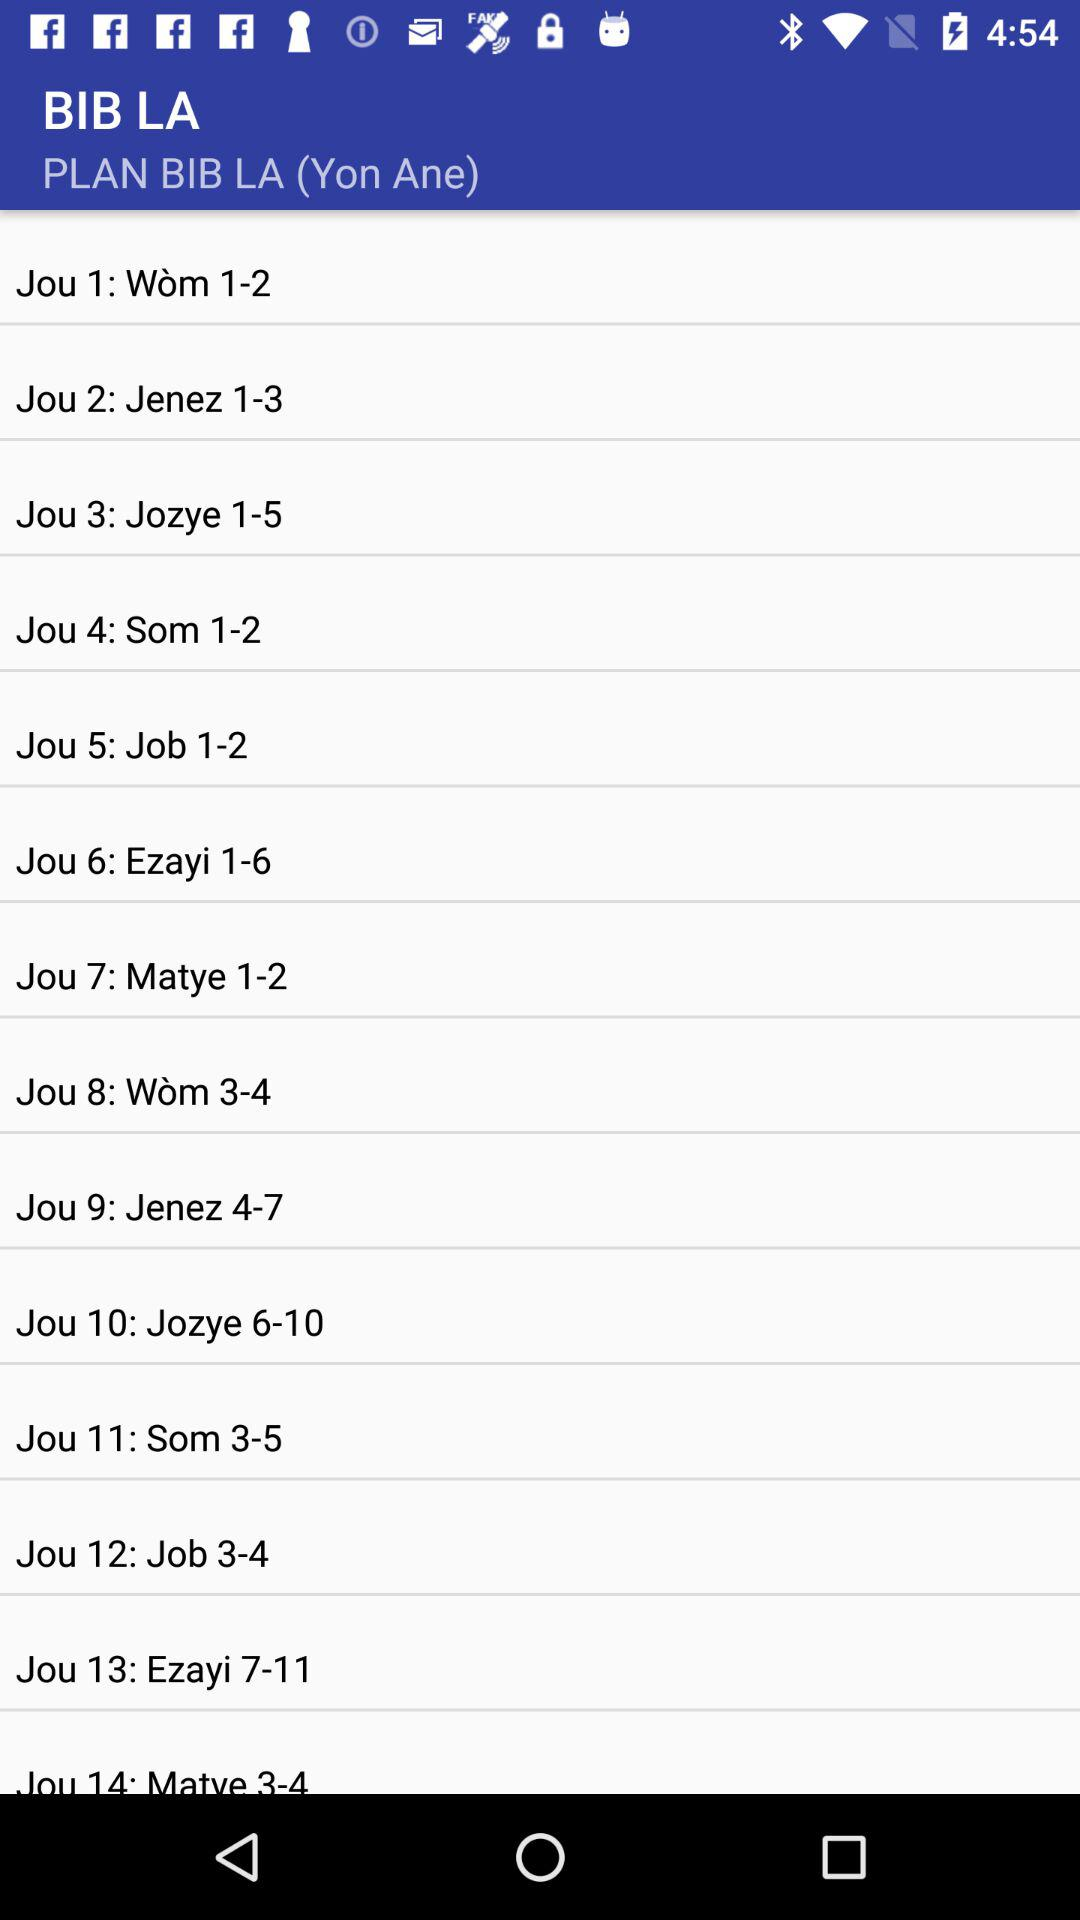How many days are in the Bible reading plan?
Answer the question using a single word or phrase. 14 